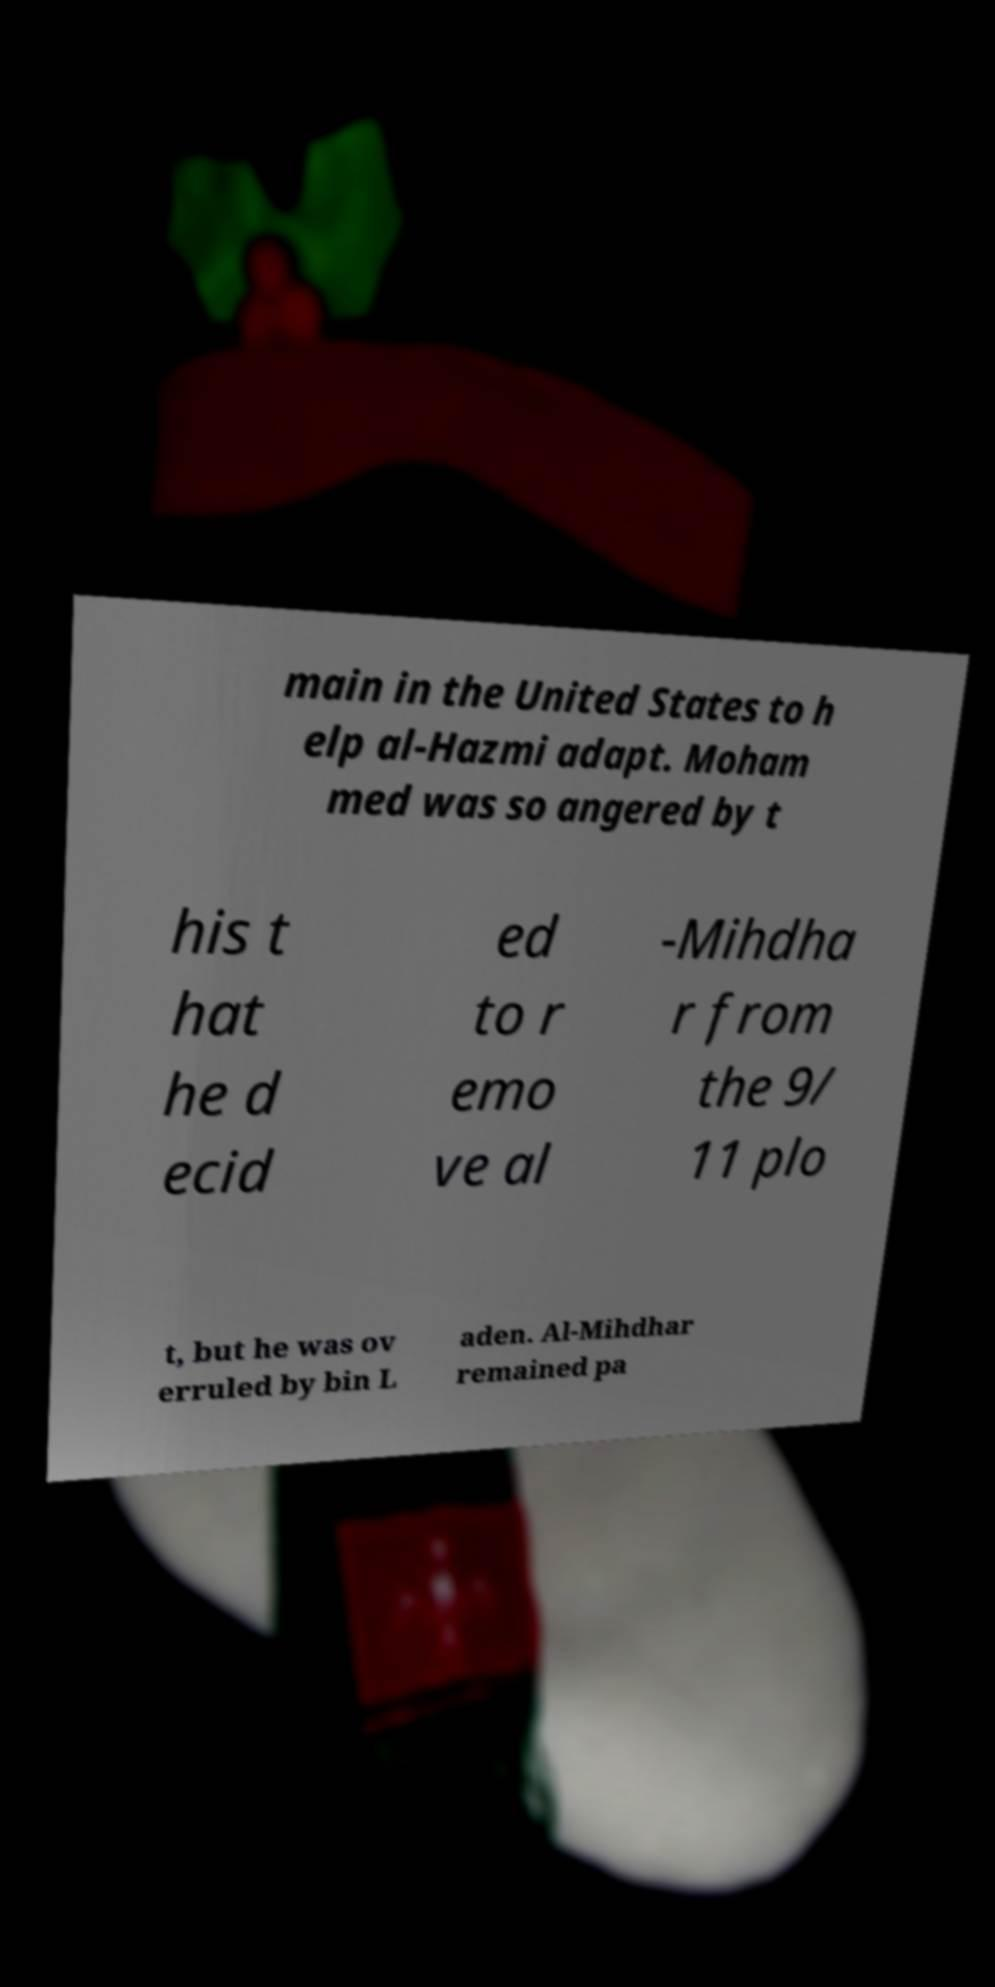Can you read and provide the text displayed in the image?This photo seems to have some interesting text. Can you extract and type it out for me? main in the United States to h elp al-Hazmi adapt. Moham med was so angered by t his t hat he d ecid ed to r emo ve al -Mihdha r from the 9/ 11 plo t, but he was ov erruled by bin L aden. Al-Mihdhar remained pa 